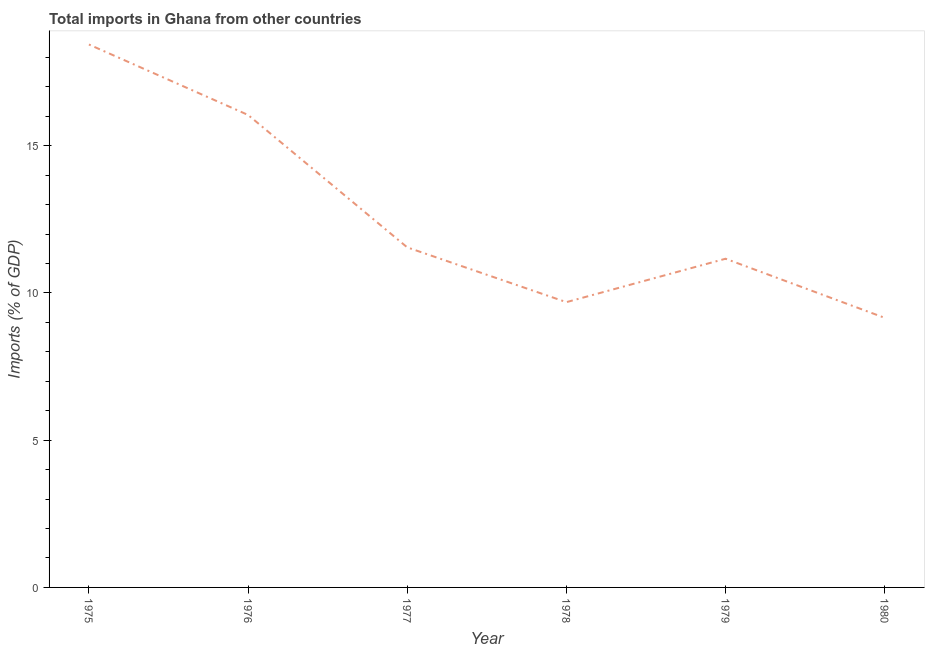What is the total imports in 1976?
Your answer should be compact. 16.04. Across all years, what is the maximum total imports?
Your response must be concise. 18.44. Across all years, what is the minimum total imports?
Provide a succinct answer. 9.15. In which year was the total imports maximum?
Make the answer very short. 1975. In which year was the total imports minimum?
Ensure brevity in your answer.  1980. What is the sum of the total imports?
Offer a terse response. 76.03. What is the difference between the total imports in 1976 and 1977?
Provide a short and direct response. 4.5. What is the average total imports per year?
Offer a terse response. 12.67. What is the median total imports?
Offer a very short reply. 11.35. What is the ratio of the total imports in 1979 to that in 1980?
Offer a terse response. 1.22. Is the total imports in 1975 less than that in 1979?
Offer a terse response. No. What is the difference between the highest and the second highest total imports?
Give a very brief answer. 2.39. Is the sum of the total imports in 1976 and 1977 greater than the maximum total imports across all years?
Provide a succinct answer. Yes. What is the difference between the highest and the lowest total imports?
Offer a terse response. 9.28. Does the total imports monotonically increase over the years?
Make the answer very short. No. How many lines are there?
Offer a very short reply. 1. What is the difference between two consecutive major ticks on the Y-axis?
Offer a terse response. 5. Are the values on the major ticks of Y-axis written in scientific E-notation?
Make the answer very short. No. Does the graph contain grids?
Make the answer very short. No. What is the title of the graph?
Provide a short and direct response. Total imports in Ghana from other countries. What is the label or title of the X-axis?
Ensure brevity in your answer.  Year. What is the label or title of the Y-axis?
Ensure brevity in your answer.  Imports (% of GDP). What is the Imports (% of GDP) of 1975?
Offer a very short reply. 18.44. What is the Imports (% of GDP) in 1976?
Offer a very short reply. 16.04. What is the Imports (% of GDP) of 1977?
Provide a short and direct response. 11.55. What is the Imports (% of GDP) of 1978?
Ensure brevity in your answer.  9.69. What is the Imports (% of GDP) of 1979?
Your answer should be very brief. 11.16. What is the Imports (% of GDP) of 1980?
Make the answer very short. 9.15. What is the difference between the Imports (% of GDP) in 1975 and 1976?
Give a very brief answer. 2.39. What is the difference between the Imports (% of GDP) in 1975 and 1977?
Ensure brevity in your answer.  6.89. What is the difference between the Imports (% of GDP) in 1975 and 1978?
Ensure brevity in your answer.  8.75. What is the difference between the Imports (% of GDP) in 1975 and 1979?
Provide a succinct answer. 7.27. What is the difference between the Imports (% of GDP) in 1975 and 1980?
Provide a succinct answer. 9.28. What is the difference between the Imports (% of GDP) in 1976 and 1977?
Offer a terse response. 4.5. What is the difference between the Imports (% of GDP) in 1976 and 1978?
Your answer should be compact. 6.36. What is the difference between the Imports (% of GDP) in 1976 and 1979?
Offer a terse response. 4.88. What is the difference between the Imports (% of GDP) in 1976 and 1980?
Your response must be concise. 6.89. What is the difference between the Imports (% of GDP) in 1977 and 1978?
Your response must be concise. 1.86. What is the difference between the Imports (% of GDP) in 1977 and 1979?
Offer a very short reply. 0.39. What is the difference between the Imports (% of GDP) in 1977 and 1980?
Ensure brevity in your answer.  2.39. What is the difference between the Imports (% of GDP) in 1978 and 1979?
Give a very brief answer. -1.47. What is the difference between the Imports (% of GDP) in 1978 and 1980?
Give a very brief answer. 0.53. What is the difference between the Imports (% of GDP) in 1979 and 1980?
Your response must be concise. 2.01. What is the ratio of the Imports (% of GDP) in 1975 to that in 1976?
Offer a very short reply. 1.15. What is the ratio of the Imports (% of GDP) in 1975 to that in 1977?
Make the answer very short. 1.6. What is the ratio of the Imports (% of GDP) in 1975 to that in 1978?
Provide a short and direct response. 1.9. What is the ratio of the Imports (% of GDP) in 1975 to that in 1979?
Keep it short and to the point. 1.65. What is the ratio of the Imports (% of GDP) in 1975 to that in 1980?
Keep it short and to the point. 2.01. What is the ratio of the Imports (% of GDP) in 1976 to that in 1977?
Your response must be concise. 1.39. What is the ratio of the Imports (% of GDP) in 1976 to that in 1978?
Your answer should be very brief. 1.66. What is the ratio of the Imports (% of GDP) in 1976 to that in 1979?
Your answer should be very brief. 1.44. What is the ratio of the Imports (% of GDP) in 1976 to that in 1980?
Provide a short and direct response. 1.75. What is the ratio of the Imports (% of GDP) in 1977 to that in 1978?
Give a very brief answer. 1.19. What is the ratio of the Imports (% of GDP) in 1977 to that in 1979?
Your response must be concise. 1.03. What is the ratio of the Imports (% of GDP) in 1977 to that in 1980?
Make the answer very short. 1.26. What is the ratio of the Imports (% of GDP) in 1978 to that in 1979?
Keep it short and to the point. 0.87. What is the ratio of the Imports (% of GDP) in 1978 to that in 1980?
Your response must be concise. 1.06. What is the ratio of the Imports (% of GDP) in 1979 to that in 1980?
Your response must be concise. 1.22. 